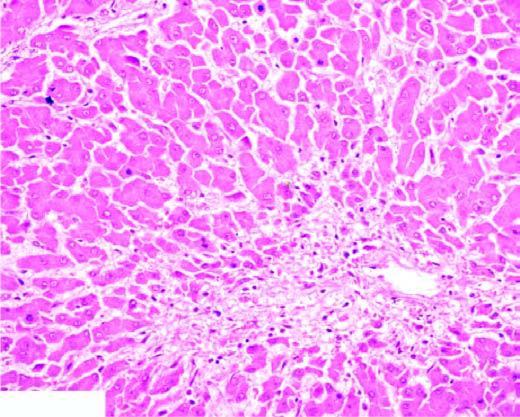what does the centrilobular zone show?
Answer the question using a single word or phrase. Marked degeneration and necrosis of hepatocytes accompanied by haemorrhage 